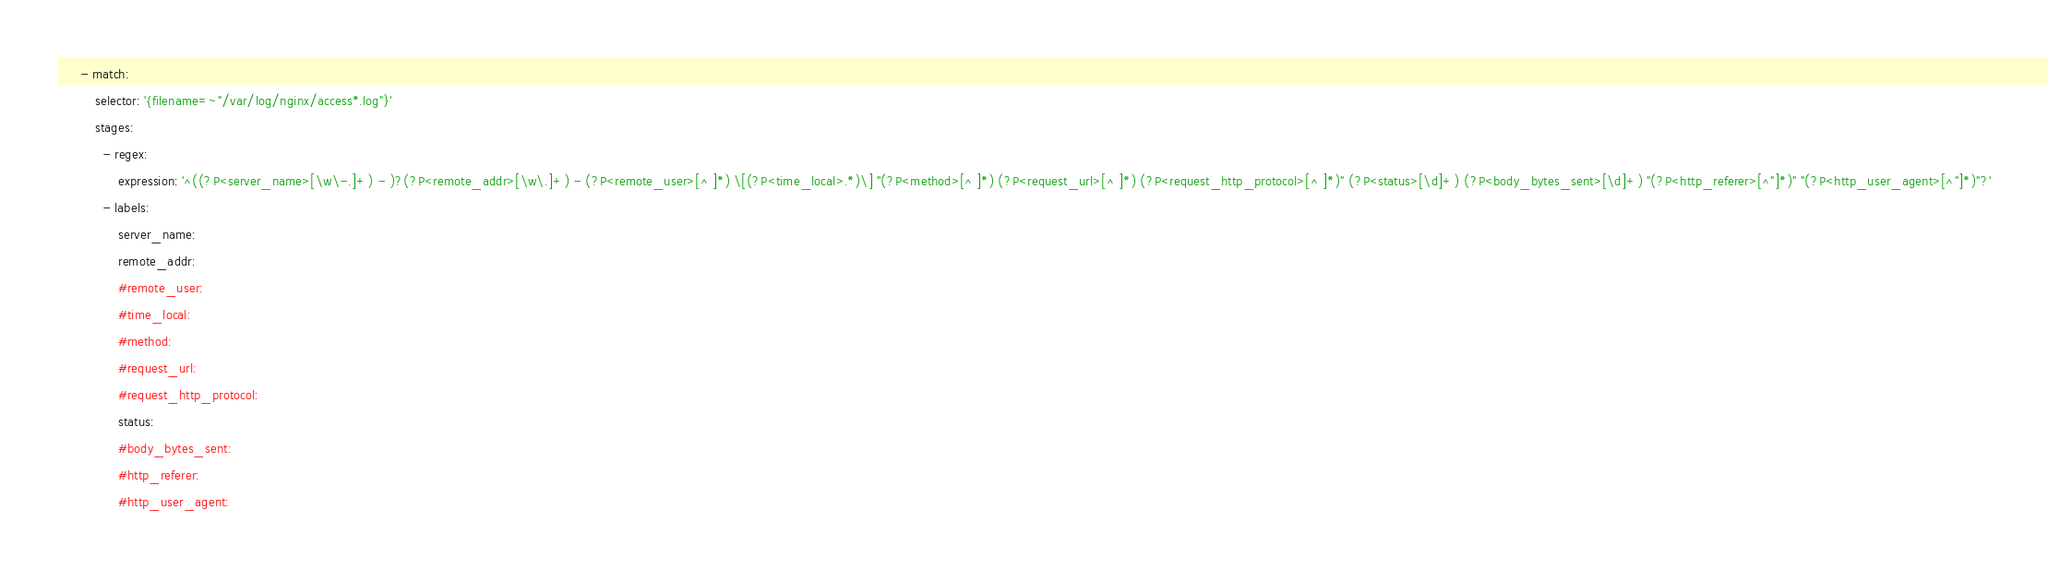<code> <loc_0><loc_0><loc_500><loc_500><_YAML_>      - match:
          selector: '{filename=~"/var/log/nginx/access*.log"}'
          stages:
            - regex:
                expression: '^((?P<server_name>[\w\-.]+) - )?(?P<remote_addr>[\w\.]+) - (?P<remote_user>[^ ]*) \[(?P<time_local>.*)\] "(?P<method>[^ ]*) (?P<request_url>[^ ]*) (?P<request_http_protocol>[^ ]*)" (?P<status>[\d]+) (?P<body_bytes_sent>[\d]+) "(?P<http_referer>[^"]*)" "(?P<http_user_agent>[^"]*)"?'
            - labels:
                server_name:
                remote_addr:
                #remote_user:
                #time_local:
                #method:
                #request_url:
                #request_http_protocol:
                status:
                #body_bytes_sent:
                #http_referer:
                #http_user_agent:</code> 